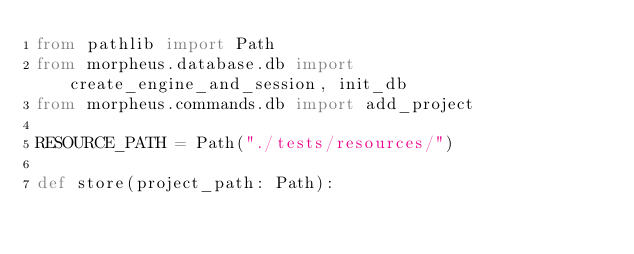Convert code to text. <code><loc_0><loc_0><loc_500><loc_500><_Python_>from pathlib import Path
from morpheus.database.db import create_engine_and_session, init_db
from morpheus.commands.db import add_project

RESOURCE_PATH = Path("./tests/resources/")

def store(project_path: Path):</code> 